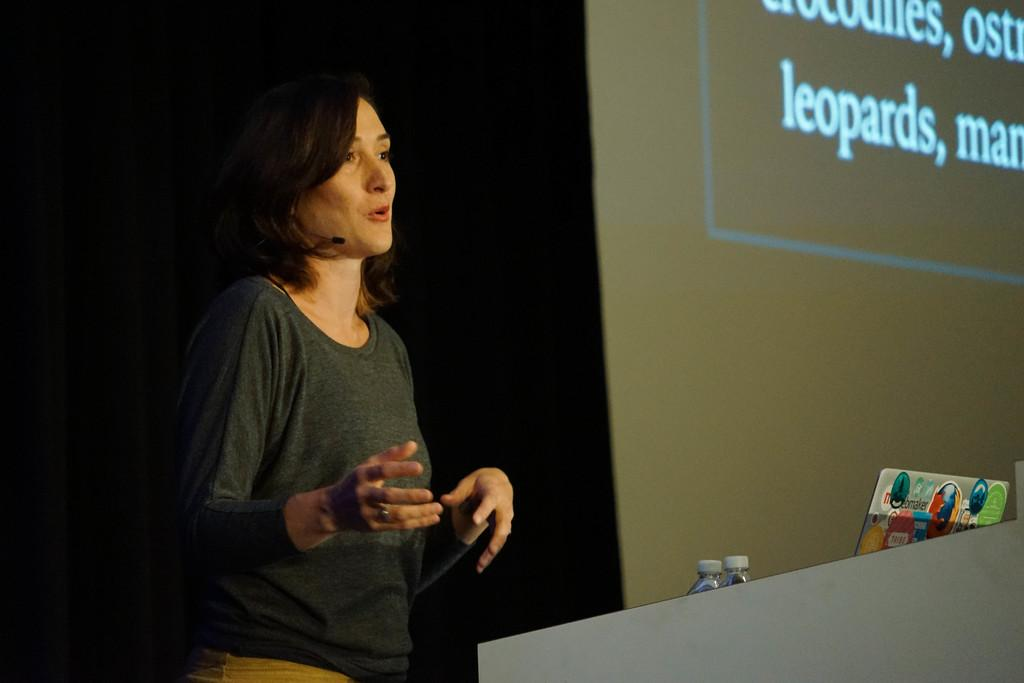Who is the main subject in the image? There is a woman in the image. What is the woman doing in the image? The woman is standing at a podium. What is the purpose of the podium in the image? The podium is likely used for presentations or speeches. What else can be seen in the image? There is a projector screen and water bottles in the image. What type of muscle is the woman flexing in the image? There is no indication in the image that the woman is flexing any muscles; she is standing at a podium. 